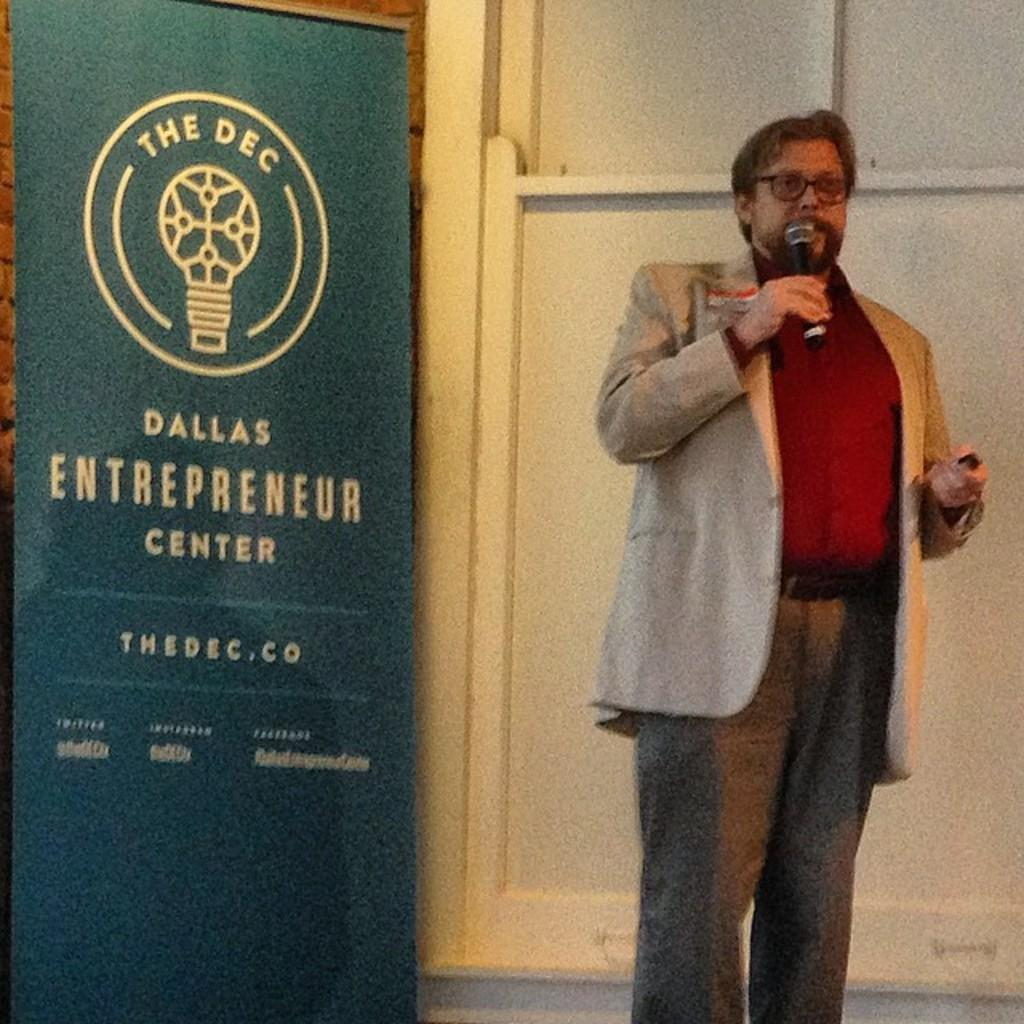<image>
Describe the image concisely. A man holding a microphone stands next to a signboard for the Dallas Entrepreneur Center. 